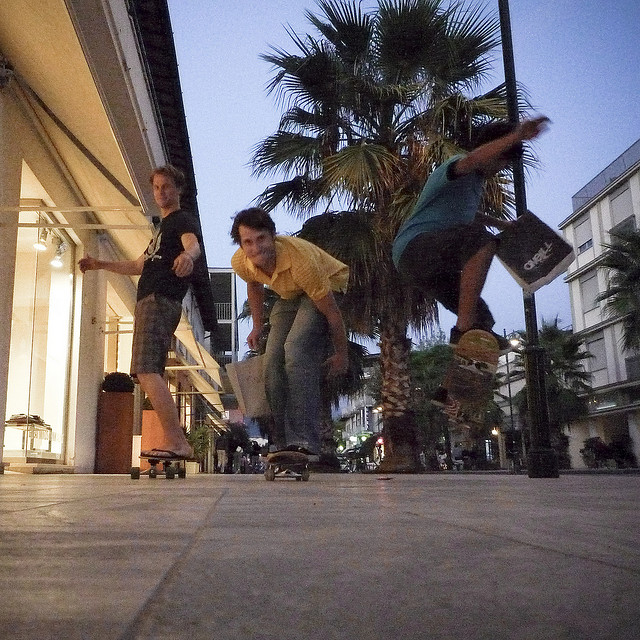<image>What color are the stars? There are no visible stars in the image. What color are the stars? The color of the stars is white. 